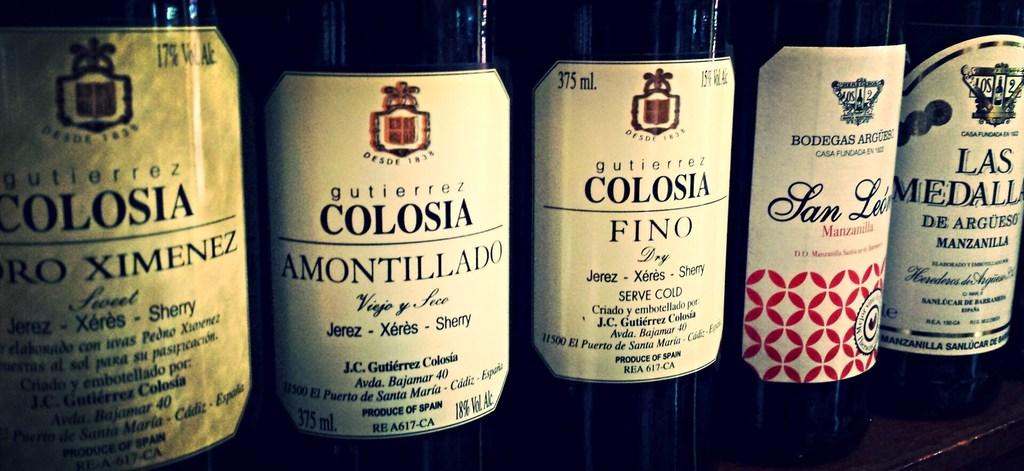How should you serve the fino?
Your answer should be compact. Cold. What is the name of the bottle on the left?
Offer a very short reply. Colosia. 